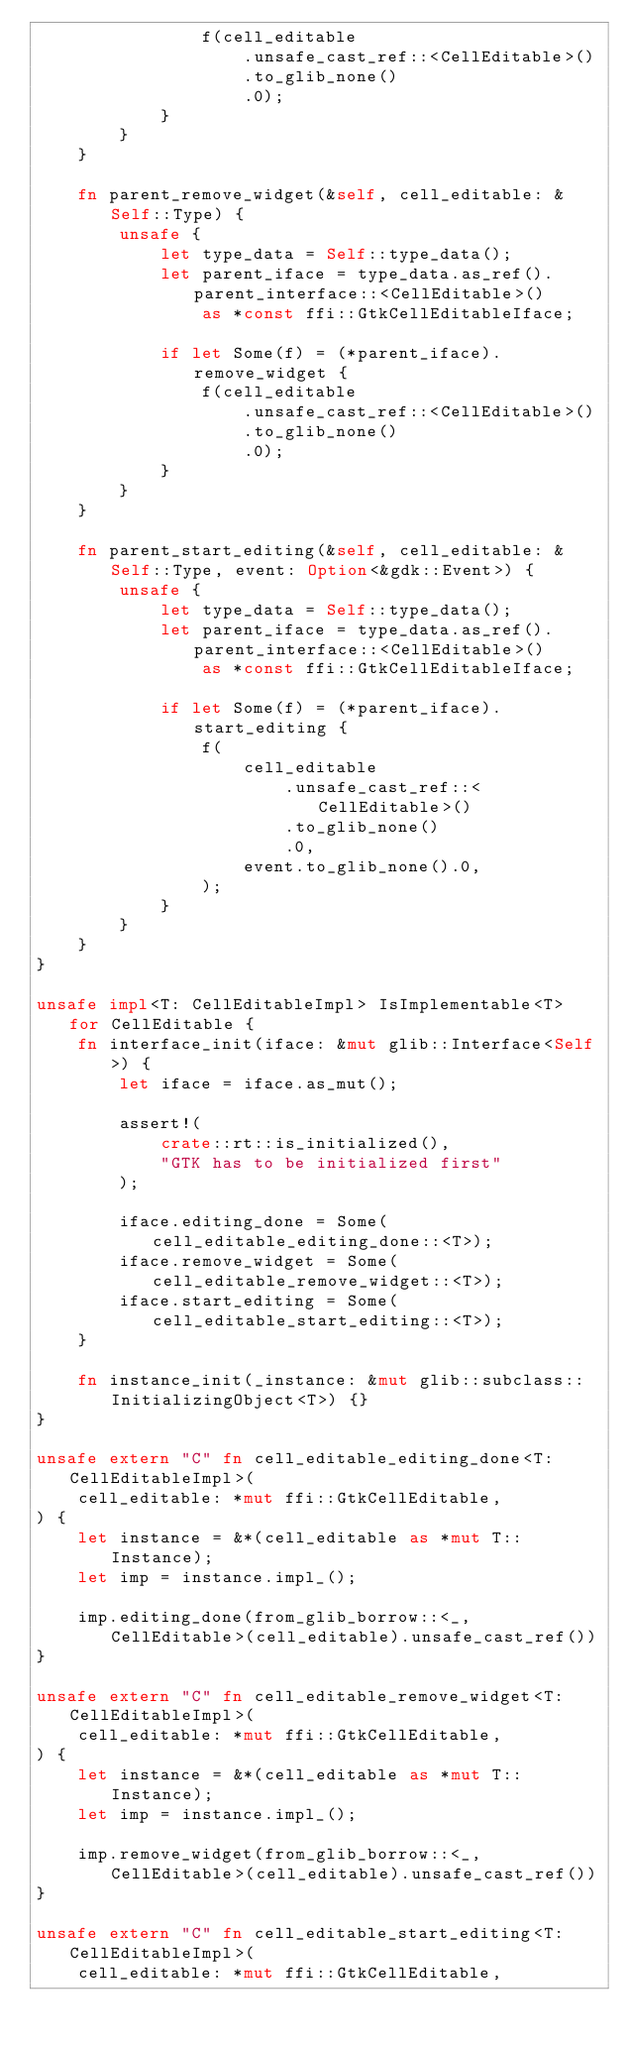Convert code to text. <code><loc_0><loc_0><loc_500><loc_500><_Rust_>                f(cell_editable
                    .unsafe_cast_ref::<CellEditable>()
                    .to_glib_none()
                    .0);
            }
        }
    }

    fn parent_remove_widget(&self, cell_editable: &Self::Type) {
        unsafe {
            let type_data = Self::type_data();
            let parent_iface = type_data.as_ref().parent_interface::<CellEditable>()
                as *const ffi::GtkCellEditableIface;

            if let Some(f) = (*parent_iface).remove_widget {
                f(cell_editable
                    .unsafe_cast_ref::<CellEditable>()
                    .to_glib_none()
                    .0);
            }
        }
    }

    fn parent_start_editing(&self, cell_editable: &Self::Type, event: Option<&gdk::Event>) {
        unsafe {
            let type_data = Self::type_data();
            let parent_iface = type_data.as_ref().parent_interface::<CellEditable>()
                as *const ffi::GtkCellEditableIface;

            if let Some(f) = (*parent_iface).start_editing {
                f(
                    cell_editable
                        .unsafe_cast_ref::<CellEditable>()
                        .to_glib_none()
                        .0,
                    event.to_glib_none().0,
                );
            }
        }
    }
}

unsafe impl<T: CellEditableImpl> IsImplementable<T> for CellEditable {
    fn interface_init(iface: &mut glib::Interface<Self>) {
        let iface = iface.as_mut();

        assert!(
            crate::rt::is_initialized(),
            "GTK has to be initialized first"
        );

        iface.editing_done = Some(cell_editable_editing_done::<T>);
        iface.remove_widget = Some(cell_editable_remove_widget::<T>);
        iface.start_editing = Some(cell_editable_start_editing::<T>);
    }

    fn instance_init(_instance: &mut glib::subclass::InitializingObject<T>) {}
}

unsafe extern "C" fn cell_editable_editing_done<T: CellEditableImpl>(
    cell_editable: *mut ffi::GtkCellEditable,
) {
    let instance = &*(cell_editable as *mut T::Instance);
    let imp = instance.impl_();

    imp.editing_done(from_glib_borrow::<_, CellEditable>(cell_editable).unsafe_cast_ref())
}

unsafe extern "C" fn cell_editable_remove_widget<T: CellEditableImpl>(
    cell_editable: *mut ffi::GtkCellEditable,
) {
    let instance = &*(cell_editable as *mut T::Instance);
    let imp = instance.impl_();

    imp.remove_widget(from_glib_borrow::<_, CellEditable>(cell_editable).unsafe_cast_ref())
}

unsafe extern "C" fn cell_editable_start_editing<T: CellEditableImpl>(
    cell_editable: *mut ffi::GtkCellEditable,</code> 